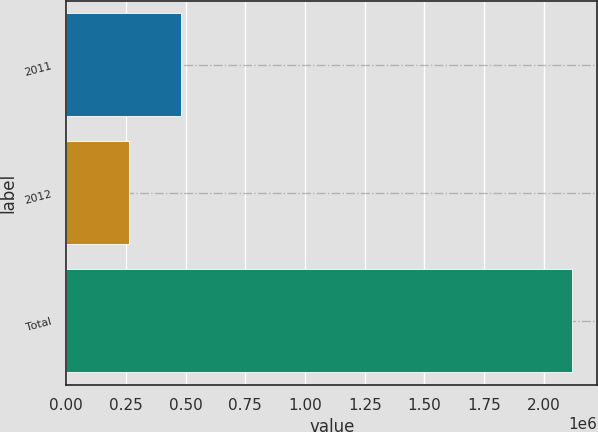Convert chart to OTSL. <chart><loc_0><loc_0><loc_500><loc_500><bar_chart><fcel>2011<fcel>2012<fcel>Total<nl><fcel>479504<fcel>261953<fcel>2.1177e+06<nl></chart> 